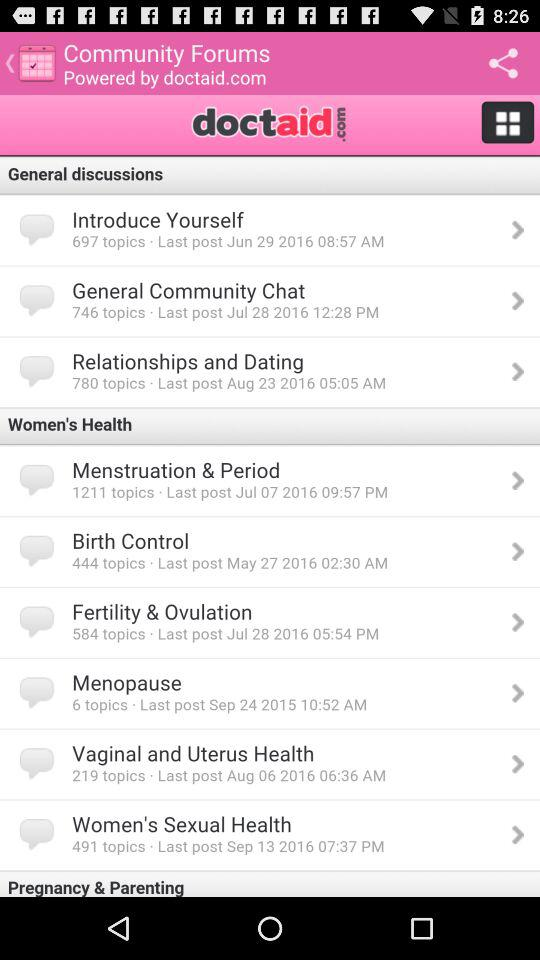How many topics are available in "Women's Sexual Health"? There are 491 available topics in "Women's Sexual Health". 